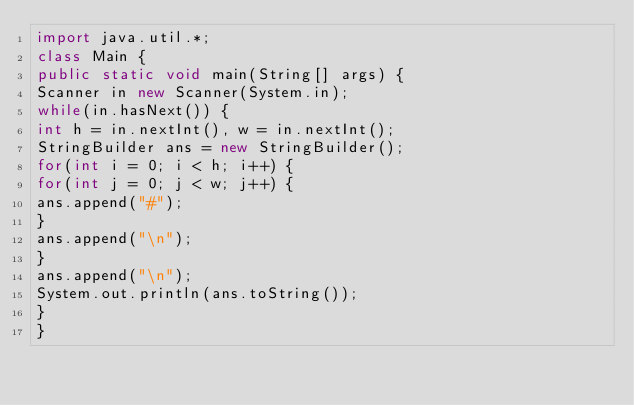<code> <loc_0><loc_0><loc_500><loc_500><_Java_>import java.util.*;
class Main {
public static void main(String[] args) {
Scanner in new Scanner(System.in);
while(in.hasNext()) {
int h = in.nextInt(), w = in.nextInt();
StringBuilder ans = new StringBuilder();
for(int i = 0; i < h; i++) {
for(int j = 0; j < w; j++) {
ans.append("#");
}
ans.append("\n");
}
ans.append("\n");
System.out.println(ans.toString());
}
}</code> 